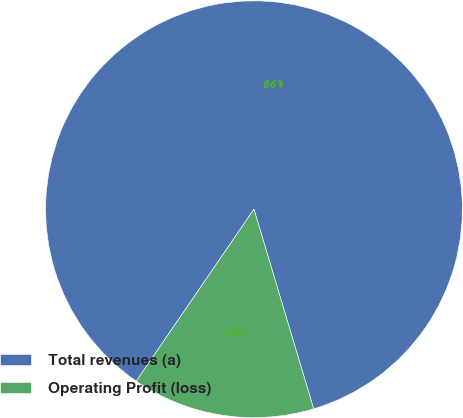Convert chart to OTSL. <chart><loc_0><loc_0><loc_500><loc_500><pie_chart><fcel>Total revenues (a)<fcel>Operating Profit (loss)<nl><fcel>85.82%<fcel>14.18%<nl></chart> 